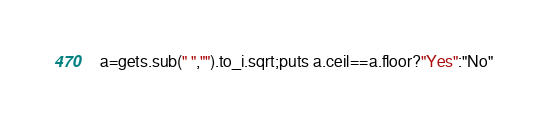<code> <loc_0><loc_0><loc_500><loc_500><_Ruby_>a=gets.sub(" ","").to_i.sqrt;puts a.ceil==a.floor?"Yes":"No"</code> 